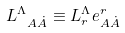Convert formula to latex. <formula><loc_0><loc_0><loc_500><loc_500>L _ { \ A \dot { A } } ^ { \Lambda } \equiv L _ { r } ^ { \Lambda } e _ { A \dot { A } } ^ { r }</formula> 